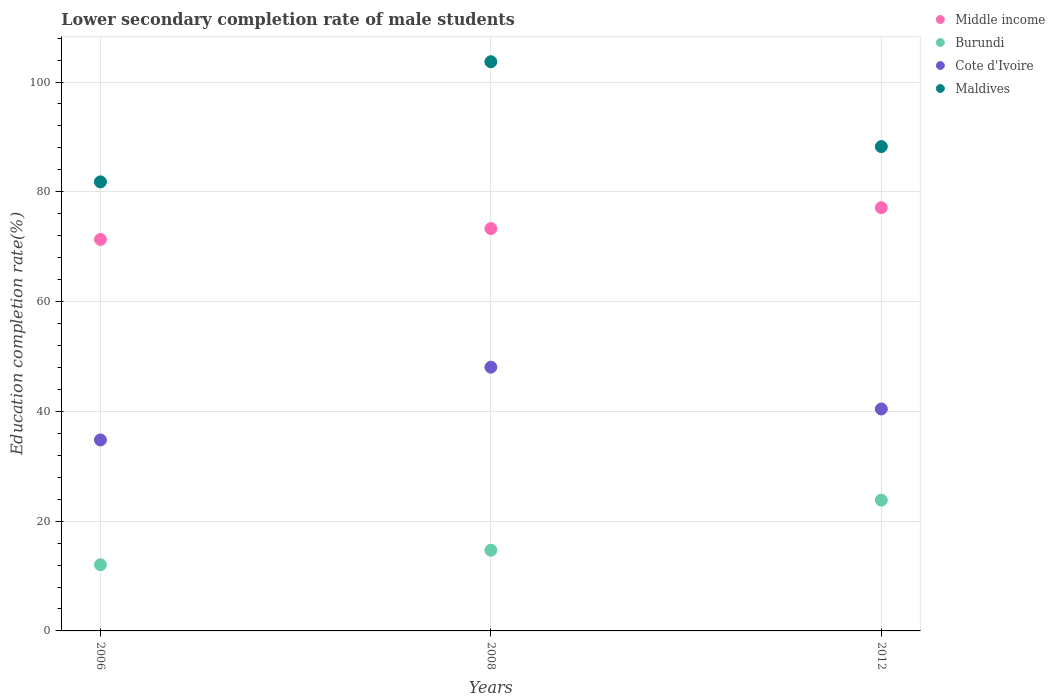How many different coloured dotlines are there?
Offer a very short reply. 4. Is the number of dotlines equal to the number of legend labels?
Keep it short and to the point. Yes. What is the lower secondary completion rate of male students in Burundi in 2006?
Your answer should be compact. 12.06. Across all years, what is the maximum lower secondary completion rate of male students in Cote d'Ivoire?
Provide a short and direct response. 48.05. Across all years, what is the minimum lower secondary completion rate of male students in Middle income?
Your response must be concise. 71.32. What is the total lower secondary completion rate of male students in Burundi in the graph?
Provide a succinct answer. 50.58. What is the difference between the lower secondary completion rate of male students in Cote d'Ivoire in 2006 and that in 2012?
Offer a very short reply. -5.64. What is the difference between the lower secondary completion rate of male students in Maldives in 2006 and the lower secondary completion rate of male students in Middle income in 2012?
Offer a terse response. 4.71. What is the average lower secondary completion rate of male students in Maldives per year?
Offer a terse response. 91.25. In the year 2008, what is the difference between the lower secondary completion rate of male students in Burundi and lower secondary completion rate of male students in Cote d'Ivoire?
Offer a terse response. -33.35. In how many years, is the lower secondary completion rate of male students in Maldives greater than 16 %?
Provide a short and direct response. 3. What is the ratio of the lower secondary completion rate of male students in Cote d'Ivoire in 2006 to that in 2008?
Offer a very short reply. 0.72. Is the difference between the lower secondary completion rate of male students in Burundi in 2006 and 2008 greater than the difference between the lower secondary completion rate of male students in Cote d'Ivoire in 2006 and 2008?
Offer a very short reply. Yes. What is the difference between the highest and the second highest lower secondary completion rate of male students in Cote d'Ivoire?
Offer a terse response. 7.62. What is the difference between the highest and the lowest lower secondary completion rate of male students in Cote d'Ivoire?
Ensure brevity in your answer.  13.26. In how many years, is the lower secondary completion rate of male students in Middle income greater than the average lower secondary completion rate of male students in Middle income taken over all years?
Give a very brief answer. 1. Is the lower secondary completion rate of male students in Burundi strictly greater than the lower secondary completion rate of male students in Middle income over the years?
Your response must be concise. No. Is the lower secondary completion rate of male students in Middle income strictly less than the lower secondary completion rate of male students in Burundi over the years?
Your answer should be very brief. No. Does the graph contain any zero values?
Your answer should be very brief. No. Does the graph contain grids?
Ensure brevity in your answer.  Yes. Where does the legend appear in the graph?
Offer a very short reply. Top right. How many legend labels are there?
Provide a succinct answer. 4. How are the legend labels stacked?
Keep it short and to the point. Vertical. What is the title of the graph?
Your response must be concise. Lower secondary completion rate of male students. Does "Libya" appear as one of the legend labels in the graph?
Make the answer very short. No. What is the label or title of the X-axis?
Offer a very short reply. Years. What is the label or title of the Y-axis?
Offer a terse response. Education completion rate(%). What is the Education completion rate(%) of Middle income in 2006?
Ensure brevity in your answer.  71.32. What is the Education completion rate(%) of Burundi in 2006?
Offer a terse response. 12.06. What is the Education completion rate(%) of Cote d'Ivoire in 2006?
Ensure brevity in your answer.  34.8. What is the Education completion rate(%) of Maldives in 2006?
Keep it short and to the point. 81.82. What is the Education completion rate(%) of Middle income in 2008?
Your answer should be very brief. 73.3. What is the Education completion rate(%) of Burundi in 2008?
Provide a succinct answer. 14.7. What is the Education completion rate(%) in Cote d'Ivoire in 2008?
Ensure brevity in your answer.  48.05. What is the Education completion rate(%) in Maldives in 2008?
Your answer should be very brief. 103.7. What is the Education completion rate(%) in Middle income in 2012?
Provide a short and direct response. 77.11. What is the Education completion rate(%) in Burundi in 2012?
Give a very brief answer. 23.83. What is the Education completion rate(%) of Cote d'Ivoire in 2012?
Your answer should be compact. 40.44. What is the Education completion rate(%) of Maldives in 2012?
Your response must be concise. 88.24. Across all years, what is the maximum Education completion rate(%) of Middle income?
Provide a short and direct response. 77.11. Across all years, what is the maximum Education completion rate(%) of Burundi?
Make the answer very short. 23.83. Across all years, what is the maximum Education completion rate(%) in Cote d'Ivoire?
Your answer should be compact. 48.05. Across all years, what is the maximum Education completion rate(%) in Maldives?
Provide a short and direct response. 103.7. Across all years, what is the minimum Education completion rate(%) in Middle income?
Your answer should be compact. 71.32. Across all years, what is the minimum Education completion rate(%) in Burundi?
Your answer should be very brief. 12.06. Across all years, what is the minimum Education completion rate(%) in Cote d'Ivoire?
Provide a succinct answer. 34.8. Across all years, what is the minimum Education completion rate(%) of Maldives?
Provide a succinct answer. 81.82. What is the total Education completion rate(%) in Middle income in the graph?
Provide a succinct answer. 221.73. What is the total Education completion rate(%) of Burundi in the graph?
Offer a very short reply. 50.58. What is the total Education completion rate(%) in Cote d'Ivoire in the graph?
Your answer should be very brief. 123.28. What is the total Education completion rate(%) in Maldives in the graph?
Provide a succinct answer. 273.75. What is the difference between the Education completion rate(%) of Middle income in 2006 and that in 2008?
Provide a succinct answer. -1.98. What is the difference between the Education completion rate(%) of Burundi in 2006 and that in 2008?
Ensure brevity in your answer.  -2.64. What is the difference between the Education completion rate(%) of Cote d'Ivoire in 2006 and that in 2008?
Give a very brief answer. -13.26. What is the difference between the Education completion rate(%) of Maldives in 2006 and that in 2008?
Offer a very short reply. -21.89. What is the difference between the Education completion rate(%) of Middle income in 2006 and that in 2012?
Provide a succinct answer. -5.79. What is the difference between the Education completion rate(%) of Burundi in 2006 and that in 2012?
Give a very brief answer. -11.77. What is the difference between the Education completion rate(%) in Cote d'Ivoire in 2006 and that in 2012?
Offer a terse response. -5.64. What is the difference between the Education completion rate(%) in Maldives in 2006 and that in 2012?
Keep it short and to the point. -6.42. What is the difference between the Education completion rate(%) of Middle income in 2008 and that in 2012?
Keep it short and to the point. -3.81. What is the difference between the Education completion rate(%) in Burundi in 2008 and that in 2012?
Your response must be concise. -9.12. What is the difference between the Education completion rate(%) in Cote d'Ivoire in 2008 and that in 2012?
Keep it short and to the point. 7.62. What is the difference between the Education completion rate(%) in Maldives in 2008 and that in 2012?
Give a very brief answer. 15.46. What is the difference between the Education completion rate(%) in Middle income in 2006 and the Education completion rate(%) in Burundi in 2008?
Your answer should be compact. 56.62. What is the difference between the Education completion rate(%) in Middle income in 2006 and the Education completion rate(%) in Cote d'Ivoire in 2008?
Your answer should be very brief. 23.27. What is the difference between the Education completion rate(%) of Middle income in 2006 and the Education completion rate(%) of Maldives in 2008?
Your response must be concise. -32.38. What is the difference between the Education completion rate(%) of Burundi in 2006 and the Education completion rate(%) of Cote d'Ivoire in 2008?
Your answer should be compact. -36. What is the difference between the Education completion rate(%) in Burundi in 2006 and the Education completion rate(%) in Maldives in 2008?
Offer a very short reply. -91.65. What is the difference between the Education completion rate(%) in Cote d'Ivoire in 2006 and the Education completion rate(%) in Maldives in 2008?
Your response must be concise. -68.91. What is the difference between the Education completion rate(%) in Middle income in 2006 and the Education completion rate(%) in Burundi in 2012?
Your answer should be very brief. 47.49. What is the difference between the Education completion rate(%) in Middle income in 2006 and the Education completion rate(%) in Cote d'Ivoire in 2012?
Your answer should be very brief. 30.88. What is the difference between the Education completion rate(%) of Middle income in 2006 and the Education completion rate(%) of Maldives in 2012?
Your answer should be very brief. -16.92. What is the difference between the Education completion rate(%) of Burundi in 2006 and the Education completion rate(%) of Cote d'Ivoire in 2012?
Ensure brevity in your answer.  -28.38. What is the difference between the Education completion rate(%) in Burundi in 2006 and the Education completion rate(%) in Maldives in 2012?
Ensure brevity in your answer.  -76.18. What is the difference between the Education completion rate(%) of Cote d'Ivoire in 2006 and the Education completion rate(%) of Maldives in 2012?
Provide a short and direct response. -53.44. What is the difference between the Education completion rate(%) in Middle income in 2008 and the Education completion rate(%) in Burundi in 2012?
Your answer should be very brief. 49.48. What is the difference between the Education completion rate(%) in Middle income in 2008 and the Education completion rate(%) in Cote d'Ivoire in 2012?
Your answer should be compact. 32.87. What is the difference between the Education completion rate(%) in Middle income in 2008 and the Education completion rate(%) in Maldives in 2012?
Ensure brevity in your answer.  -14.93. What is the difference between the Education completion rate(%) of Burundi in 2008 and the Education completion rate(%) of Cote d'Ivoire in 2012?
Your answer should be very brief. -25.73. What is the difference between the Education completion rate(%) in Burundi in 2008 and the Education completion rate(%) in Maldives in 2012?
Provide a succinct answer. -73.54. What is the difference between the Education completion rate(%) of Cote d'Ivoire in 2008 and the Education completion rate(%) of Maldives in 2012?
Make the answer very short. -40.19. What is the average Education completion rate(%) in Middle income per year?
Provide a succinct answer. 73.91. What is the average Education completion rate(%) of Burundi per year?
Ensure brevity in your answer.  16.86. What is the average Education completion rate(%) in Cote d'Ivoire per year?
Offer a very short reply. 41.09. What is the average Education completion rate(%) in Maldives per year?
Provide a succinct answer. 91.25. In the year 2006, what is the difference between the Education completion rate(%) of Middle income and Education completion rate(%) of Burundi?
Keep it short and to the point. 59.26. In the year 2006, what is the difference between the Education completion rate(%) in Middle income and Education completion rate(%) in Cote d'Ivoire?
Provide a succinct answer. 36.52. In the year 2006, what is the difference between the Education completion rate(%) in Middle income and Education completion rate(%) in Maldives?
Ensure brevity in your answer.  -10.5. In the year 2006, what is the difference between the Education completion rate(%) in Burundi and Education completion rate(%) in Cote d'Ivoire?
Your response must be concise. -22.74. In the year 2006, what is the difference between the Education completion rate(%) of Burundi and Education completion rate(%) of Maldives?
Your answer should be very brief. -69.76. In the year 2006, what is the difference between the Education completion rate(%) in Cote d'Ivoire and Education completion rate(%) in Maldives?
Offer a terse response. -47.02. In the year 2008, what is the difference between the Education completion rate(%) of Middle income and Education completion rate(%) of Burundi?
Make the answer very short. 58.6. In the year 2008, what is the difference between the Education completion rate(%) in Middle income and Education completion rate(%) in Cote d'Ivoire?
Your answer should be compact. 25.25. In the year 2008, what is the difference between the Education completion rate(%) in Middle income and Education completion rate(%) in Maldives?
Your answer should be compact. -30.4. In the year 2008, what is the difference between the Education completion rate(%) in Burundi and Education completion rate(%) in Cote d'Ivoire?
Give a very brief answer. -33.35. In the year 2008, what is the difference between the Education completion rate(%) of Burundi and Education completion rate(%) of Maldives?
Offer a terse response. -89. In the year 2008, what is the difference between the Education completion rate(%) of Cote d'Ivoire and Education completion rate(%) of Maldives?
Provide a succinct answer. -55.65. In the year 2012, what is the difference between the Education completion rate(%) of Middle income and Education completion rate(%) of Burundi?
Make the answer very short. 53.28. In the year 2012, what is the difference between the Education completion rate(%) in Middle income and Education completion rate(%) in Cote d'Ivoire?
Provide a short and direct response. 36.67. In the year 2012, what is the difference between the Education completion rate(%) of Middle income and Education completion rate(%) of Maldives?
Ensure brevity in your answer.  -11.13. In the year 2012, what is the difference between the Education completion rate(%) in Burundi and Education completion rate(%) in Cote d'Ivoire?
Offer a very short reply. -16.61. In the year 2012, what is the difference between the Education completion rate(%) of Burundi and Education completion rate(%) of Maldives?
Your response must be concise. -64.41. In the year 2012, what is the difference between the Education completion rate(%) in Cote d'Ivoire and Education completion rate(%) in Maldives?
Your answer should be compact. -47.8. What is the ratio of the Education completion rate(%) in Middle income in 2006 to that in 2008?
Your answer should be very brief. 0.97. What is the ratio of the Education completion rate(%) of Burundi in 2006 to that in 2008?
Make the answer very short. 0.82. What is the ratio of the Education completion rate(%) of Cote d'Ivoire in 2006 to that in 2008?
Offer a very short reply. 0.72. What is the ratio of the Education completion rate(%) of Maldives in 2006 to that in 2008?
Provide a short and direct response. 0.79. What is the ratio of the Education completion rate(%) in Middle income in 2006 to that in 2012?
Give a very brief answer. 0.92. What is the ratio of the Education completion rate(%) in Burundi in 2006 to that in 2012?
Make the answer very short. 0.51. What is the ratio of the Education completion rate(%) in Cote d'Ivoire in 2006 to that in 2012?
Make the answer very short. 0.86. What is the ratio of the Education completion rate(%) of Maldives in 2006 to that in 2012?
Give a very brief answer. 0.93. What is the ratio of the Education completion rate(%) of Middle income in 2008 to that in 2012?
Offer a terse response. 0.95. What is the ratio of the Education completion rate(%) of Burundi in 2008 to that in 2012?
Your response must be concise. 0.62. What is the ratio of the Education completion rate(%) in Cote d'Ivoire in 2008 to that in 2012?
Ensure brevity in your answer.  1.19. What is the ratio of the Education completion rate(%) of Maldives in 2008 to that in 2012?
Provide a succinct answer. 1.18. What is the difference between the highest and the second highest Education completion rate(%) in Middle income?
Make the answer very short. 3.81. What is the difference between the highest and the second highest Education completion rate(%) in Burundi?
Give a very brief answer. 9.12. What is the difference between the highest and the second highest Education completion rate(%) of Cote d'Ivoire?
Make the answer very short. 7.62. What is the difference between the highest and the second highest Education completion rate(%) of Maldives?
Offer a very short reply. 15.46. What is the difference between the highest and the lowest Education completion rate(%) in Middle income?
Make the answer very short. 5.79. What is the difference between the highest and the lowest Education completion rate(%) of Burundi?
Make the answer very short. 11.77. What is the difference between the highest and the lowest Education completion rate(%) in Cote d'Ivoire?
Ensure brevity in your answer.  13.26. What is the difference between the highest and the lowest Education completion rate(%) of Maldives?
Your response must be concise. 21.89. 